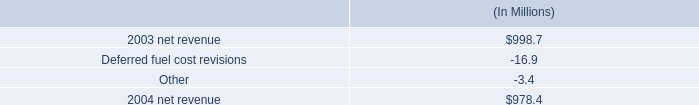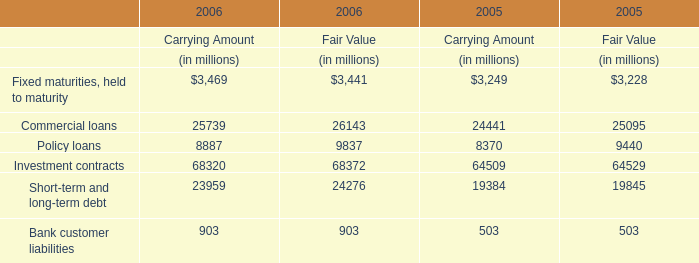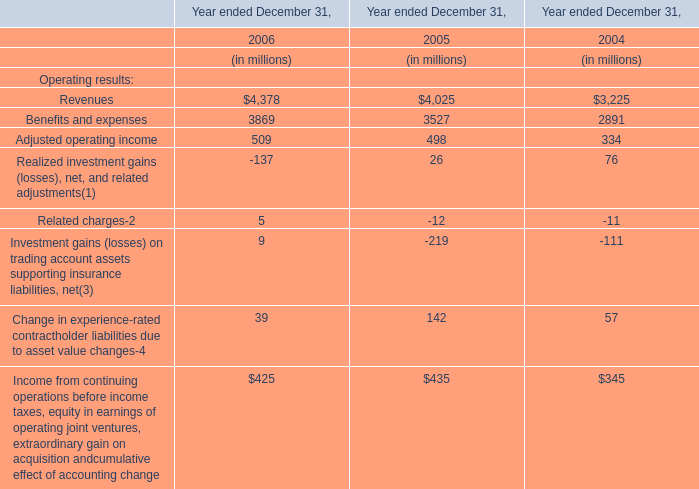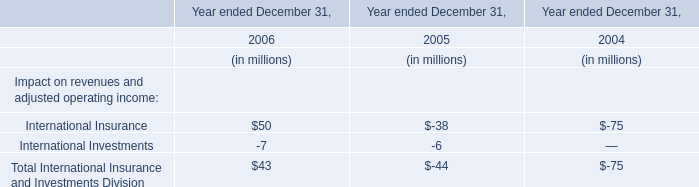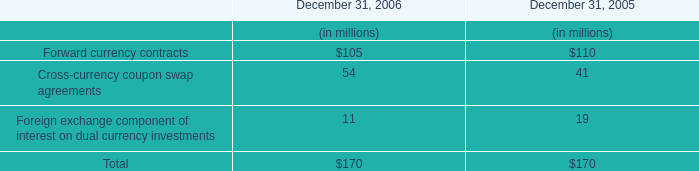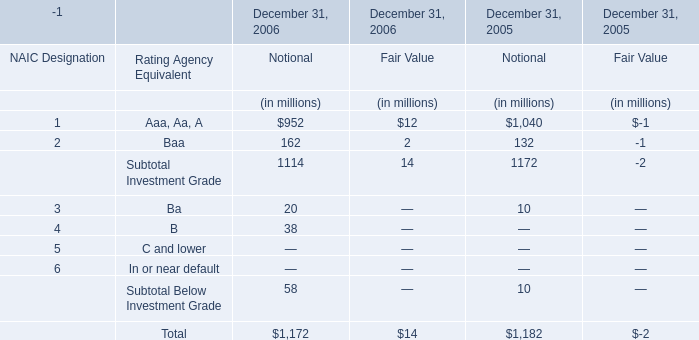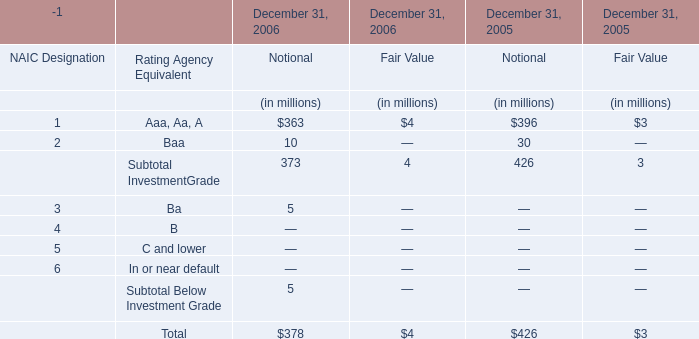what is the percent change in net revenue from 2003 to 2004? 
Computations: ((998.7 - 978.4) / 978.4)
Answer: 0.02075. 